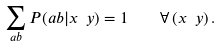Convert formula to latex. <formula><loc_0><loc_0><loc_500><loc_500>\sum _ { a b } P ( a b | x \ y ) = 1 \quad \forall \, ( x \ y ) \, .</formula> 